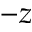Convert formula to latex. <formula><loc_0><loc_0><loc_500><loc_500>- z</formula> 